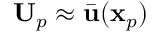Convert formula to latex. <formula><loc_0><loc_0><loc_500><loc_500>U _ { p } \approx \bar { u } ( x _ { p } )</formula> 